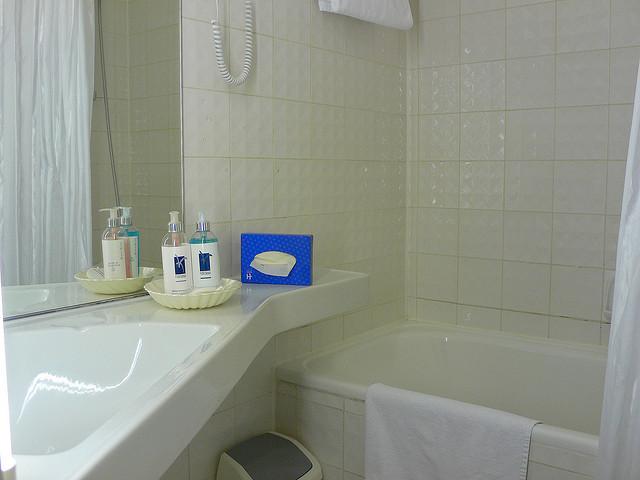How many bottles are sitting on the counter?
Short answer required. 2. Could this scene be from a hotel room bathroom?
Short answer required. Yes. Does the dangling chord belong to a telephone?
Quick response, please. Yes. 